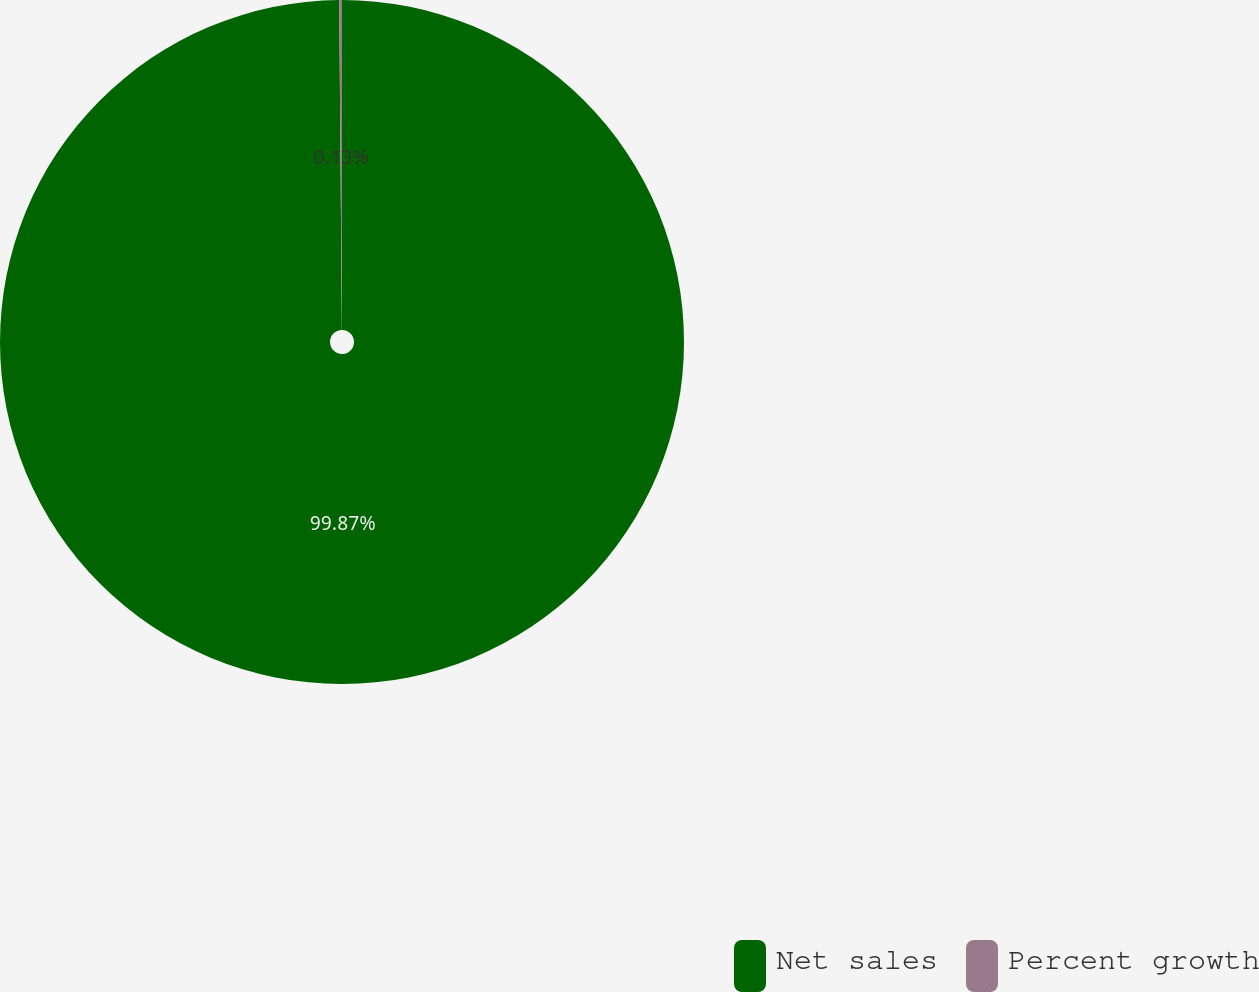Convert chart. <chart><loc_0><loc_0><loc_500><loc_500><pie_chart><fcel>Net sales<fcel>Percent growth<nl><fcel>99.87%<fcel>0.13%<nl></chart> 